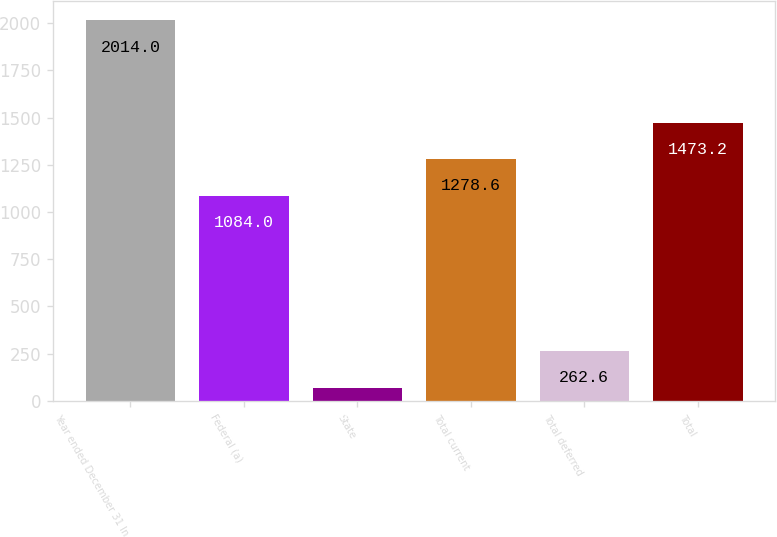<chart> <loc_0><loc_0><loc_500><loc_500><bar_chart><fcel>Year ended December 31 In<fcel>Federal (a)<fcel>State<fcel>Total current<fcel>Total deferred<fcel>Total<nl><fcel>2014<fcel>1084<fcel>68<fcel>1278.6<fcel>262.6<fcel>1473.2<nl></chart> 